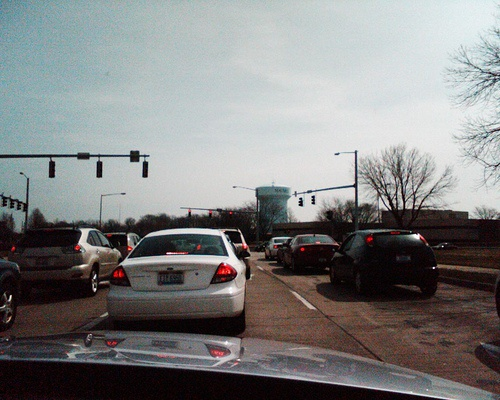Describe the objects in this image and their specific colors. I can see car in gray, black, and darkgray tones, car in gray, black, lightgray, and maroon tones, car in gray, black, maroon, and darkgray tones, car in gray, black, maroon, and purple tones, and car in gray, black, maroon, and teal tones in this image. 